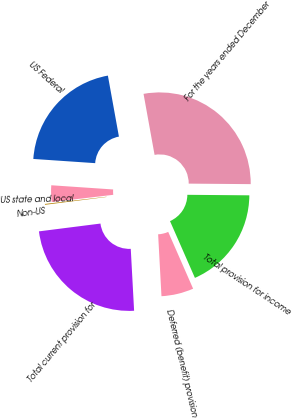Convert chart. <chart><loc_0><loc_0><loc_500><loc_500><pie_chart><fcel>For the years ended December<fcel>US Federal<fcel>US state and local<fcel>Non-US<fcel>Total current provision for<fcel>Deferred (benefit) provision<fcel>Total provision for income<nl><fcel>27.98%<fcel>21.07%<fcel>2.94%<fcel>0.15%<fcel>23.85%<fcel>5.72%<fcel>18.29%<nl></chart> 